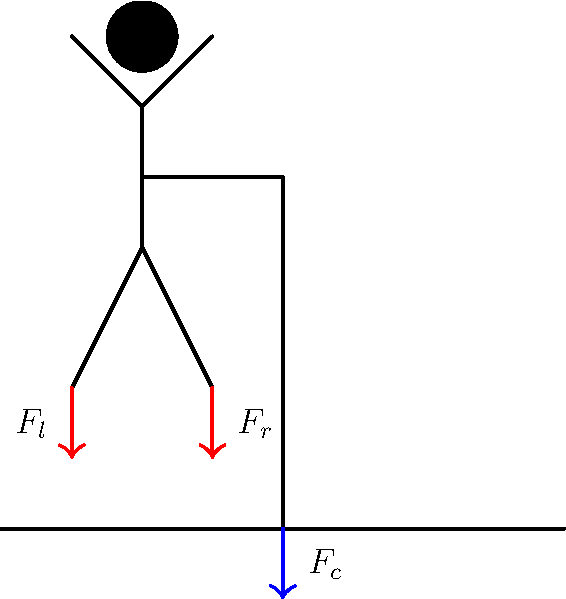A patient using a cane applies a downward force $F_c$ on the cane. If the total body weight is $W$ and the force on the left leg (without the cane) is $F_l$, what is the force $F_r$ on the right leg in terms of $W$ and $F_c$, assuming static equilibrium? To solve this problem, we'll use the principles of static equilibrium and force distribution. Let's follow these steps:

1) In static equilibrium, the sum of all vertical forces must equal zero:
   $F_l + F_r + F_c - W = 0$

2) We can rearrange this equation to solve for $F_r$:
   $F_r = W - F_l - F_c$

3) However, we don't know the value of $F_l$. We need to consider the distribution of forces between the legs and the cane.

4) In a balanced stance with a cane, the force on the leg opposite the cane (left leg in this case) is typically about 20% of body weight, while the cane takes about 15-20% of body weight.

5) Let's express $F_l$ and $F_c$ in terms of $W$:
   $F_l ≈ 0.2W$
   $F_c ≈ 0.2W$

6) Substituting these into our equation from step 2:
   $F_r = W - 0.2W - 0.2W = 0.6W$

7) Therefore, the force on the right leg is approximately 60% of the total body weight.

This distribution helps reduce the load on the affected leg (usually the one on the same side as the cane) while maintaining stability. It's important to note that these percentages can vary based on the individual's condition and cane usage technique.
Answer: $F_r ≈ 0.6W$ 